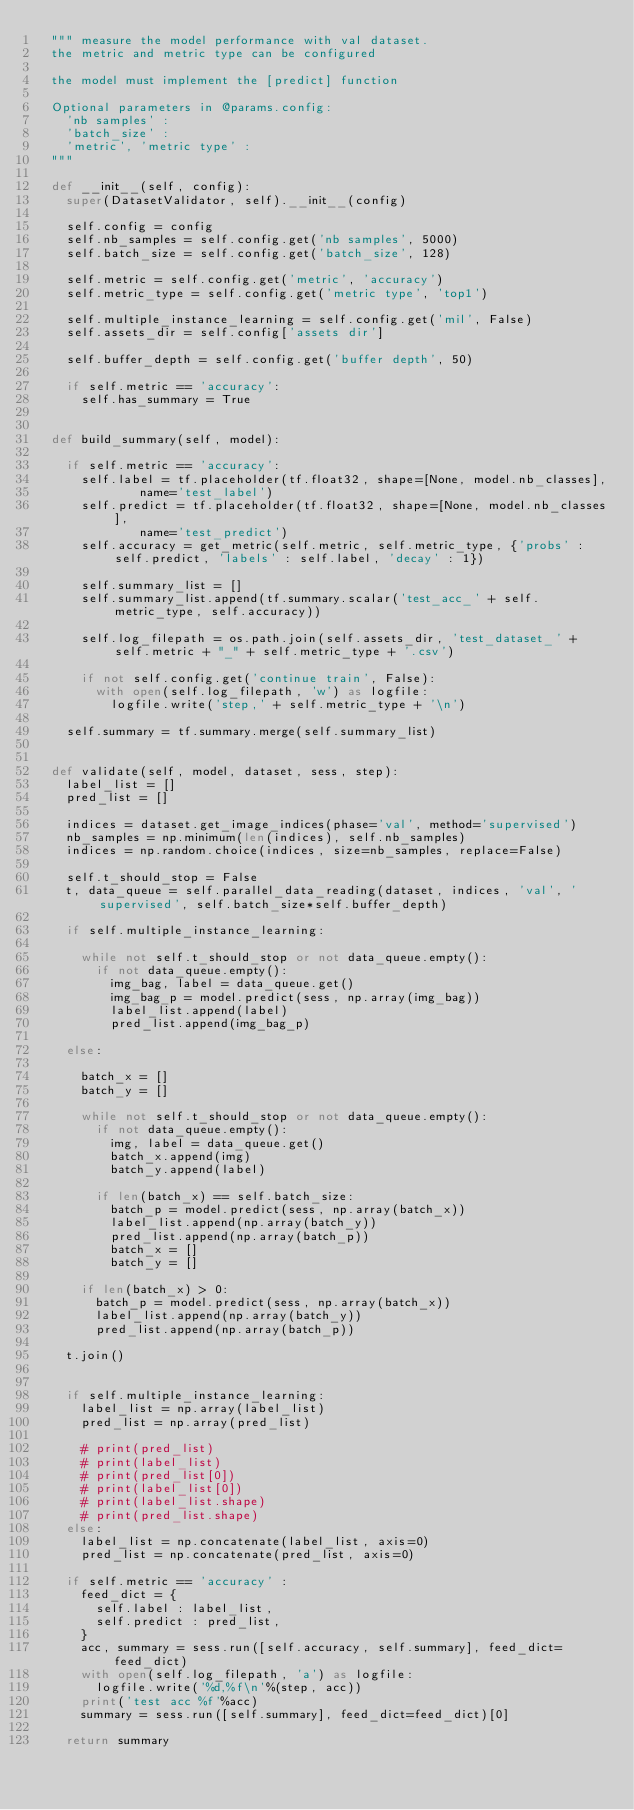Convert code to text. <code><loc_0><loc_0><loc_500><loc_500><_Python_>	""" measure the model performance with val dataset.
	the metric and metric type can be configured

	the model must implement the [predict] function

	Optional parameters in @params.config:
		'nb samples' : 
		'batch_size' : 
		'metric', 'metric type' : 
	"""

	def __init__(self, config):
		super(DatasetValidator, self).__init__(config)

		self.config = config
		self.nb_samples = self.config.get('nb samples', 5000)
		self.batch_size = self.config.get('batch_size', 128)

		self.metric = self.config.get('metric', 'accuracy')
		self.metric_type = self.config.get('metric type', 'top1')

		self.multiple_instance_learning = self.config.get('mil', False)
		self.assets_dir = self.config['assets dir']

		self.buffer_depth = self.config.get('buffer depth', 50)

		if self.metric == 'accuracy':
			self.has_summary = True


	def build_summary(self, model):

		if self.metric == 'accuracy':
			self.label = tf.placeholder(tf.float32, shape=[None, model.nb_classes],
							name='test_label')
			self.predict = tf.placeholder(tf.float32, shape=[None, model.nb_classes],
							name='test_predict')
			self.accuracy = get_metric(self.metric, self.metric_type, {'probs' : self.predict, 'labels' : self.label, 'decay' : 1})

			self.summary_list = []
			self.summary_list.append(tf.summary.scalar('test_acc_' + self.metric_type, self.accuracy))

			self.log_filepath = os.path.join(self.assets_dir, 'test_dataset_' + self.metric + "_" + self.metric_type + '.csv')

			if not self.config.get('continue train', False):
				with open(self.log_filepath, 'w') as logfile:
					logfile.write('step,' + self.metric_type + '\n')
		
		self.summary = tf.summary.merge(self.summary_list)


	def validate(self, model, dataset, sess, step):
		label_list = []
		pred_list = []

		indices = dataset.get_image_indices(phase='val', method='supervised')
		nb_samples = np.minimum(len(indices), self.nb_samples)
		indices = np.random.choice(indices, size=nb_samples, replace=False)

		self.t_should_stop = False
		t, data_queue = self.parallel_data_reading(dataset, indices, 'val', 'supervised', self.batch_size*self.buffer_depth)

		if self.multiple_instance_learning:

			while not self.t_should_stop or not data_queue.empty():
				if not data_queue.empty():
					img_bag, label = data_queue.get()
					img_bag_p = model.predict(sess, np.array(img_bag))
					label_list.append(label)
					pred_list.append(img_bag_p)

		else:
				
			batch_x = []
			batch_y = []

			while not self.t_should_stop or not data_queue.empty():
				if not data_queue.empty():
					img, label = data_queue.get()
					batch_x.append(img)
					batch_y.append(label)

				if len(batch_x) == self.batch_size:
					batch_p = model.predict(sess, np.array(batch_x))
					label_list.append(np.array(batch_y))
					pred_list.append(np.array(batch_p))
					batch_x = []
					batch_y = []

			if len(batch_x) > 0:
				batch_p = model.predict(sess, np.array(batch_x))
				label_list.append(np.array(batch_y))
				pred_list.append(np.array(batch_p))

		t.join()


		if self.multiple_instance_learning:
			label_list = np.array(label_list)
			pred_list = np.array(pred_list)

			# print(pred_list)
			# print(label_list)
			# print(pred_list[0])
			# print(label_list[0])
			# print(label_list.shape)
			# print(pred_list.shape)
		else:
			label_list = np.concatenate(label_list, axis=0)
			pred_list = np.concatenate(pred_list, axis=0)

		if self.metric == 'accuracy' : 
			feed_dict = {
				self.label : label_list,
				self.predict : pred_list,
			}
			acc, summary = sess.run([self.accuracy, self.summary], feed_dict=feed_dict)
			with open(self.log_filepath, 'a') as logfile:
				logfile.write('%d,%f\n'%(step, acc))
			print('test acc %f'%acc)
			summary = sess.run([self.summary], feed_dict=feed_dict)[0]

		return summary


</code> 